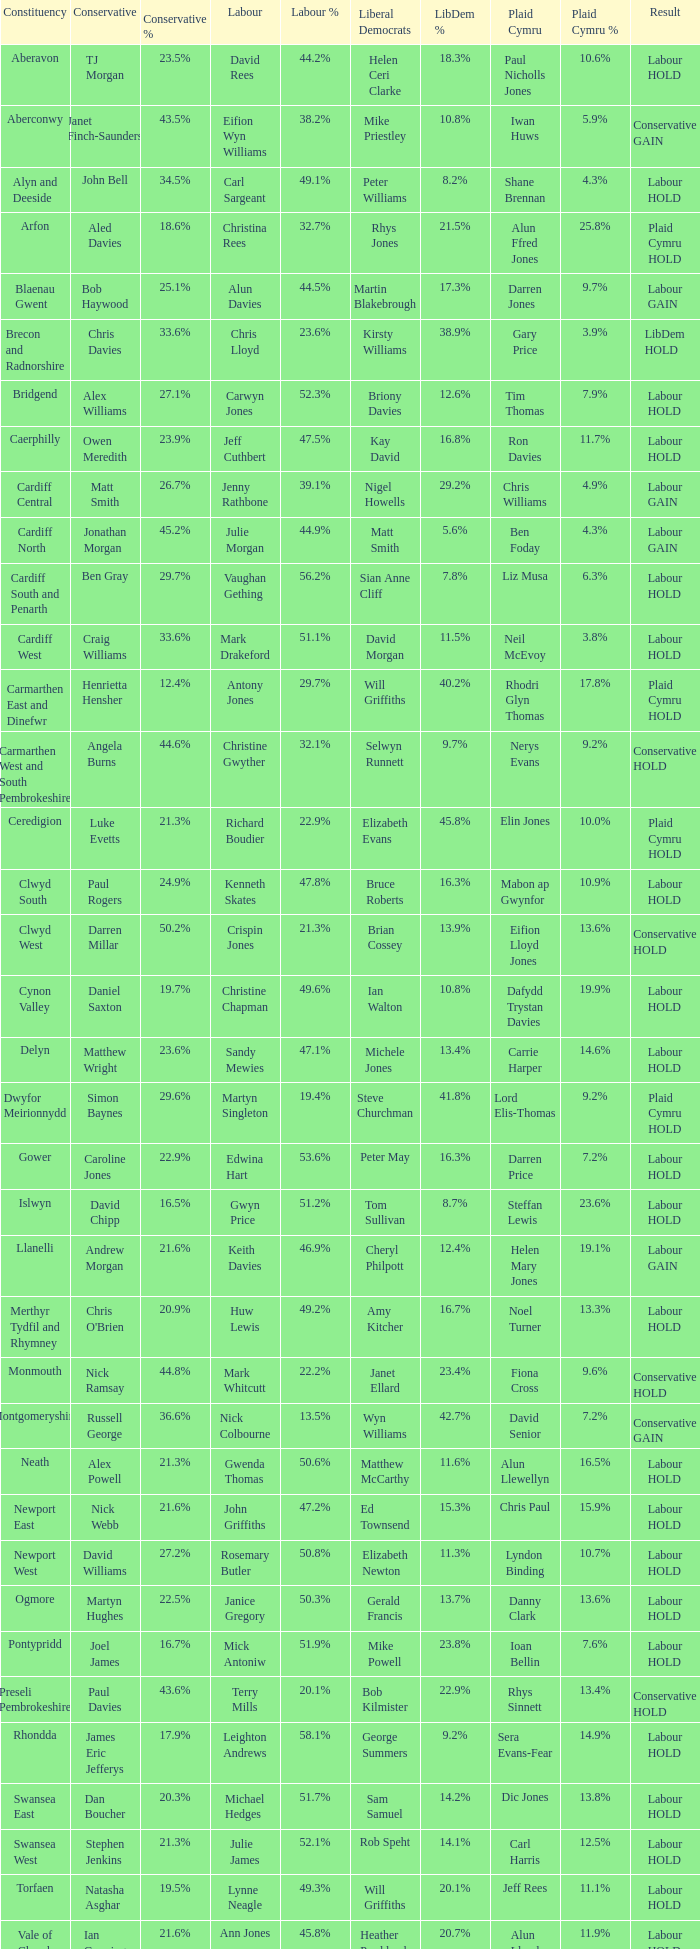In what constituency was the result labour hold and Liberal democrat Elizabeth Newton won? Newport West. 